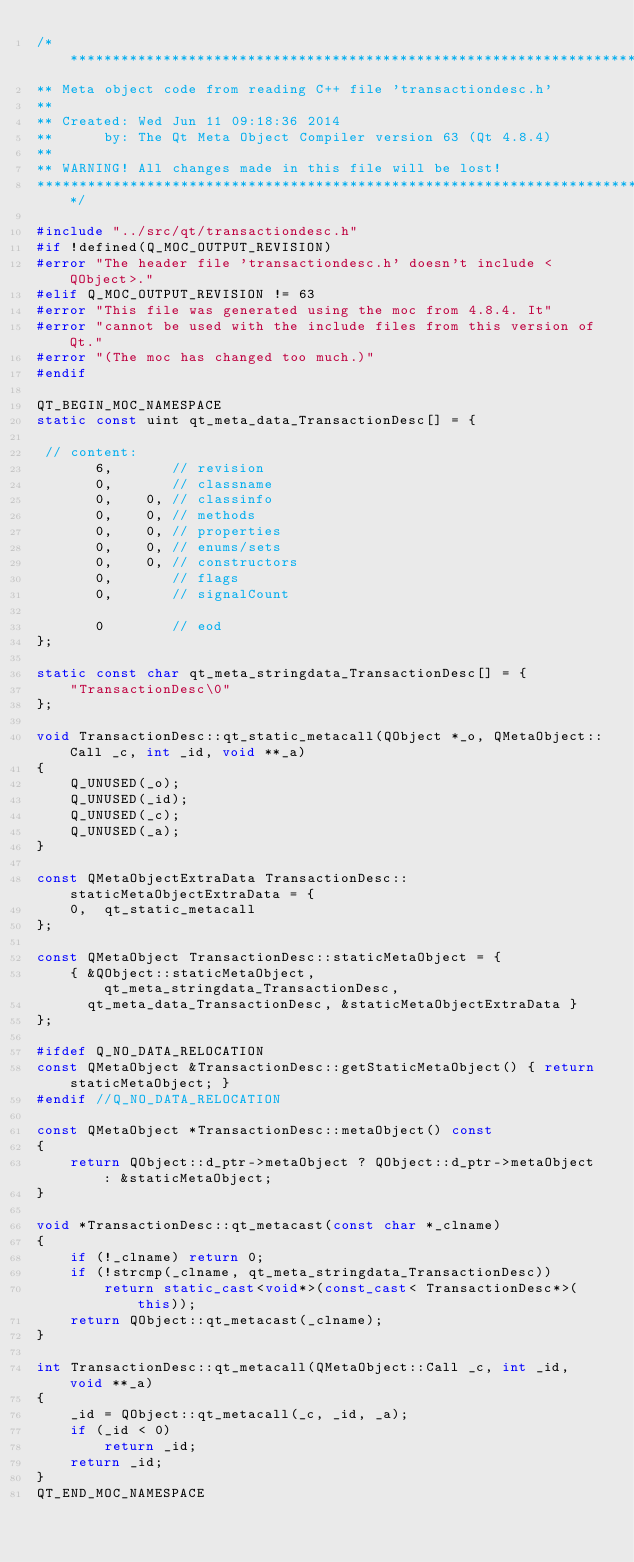Convert code to text. <code><loc_0><loc_0><loc_500><loc_500><_C++_>/****************************************************************************
** Meta object code from reading C++ file 'transactiondesc.h'
**
** Created: Wed Jun 11 09:18:36 2014
**      by: The Qt Meta Object Compiler version 63 (Qt 4.8.4)
**
** WARNING! All changes made in this file will be lost!
*****************************************************************************/

#include "../src/qt/transactiondesc.h"
#if !defined(Q_MOC_OUTPUT_REVISION)
#error "The header file 'transactiondesc.h' doesn't include <QObject>."
#elif Q_MOC_OUTPUT_REVISION != 63
#error "This file was generated using the moc from 4.8.4. It"
#error "cannot be used with the include files from this version of Qt."
#error "(The moc has changed too much.)"
#endif

QT_BEGIN_MOC_NAMESPACE
static const uint qt_meta_data_TransactionDesc[] = {

 // content:
       6,       // revision
       0,       // classname
       0,    0, // classinfo
       0,    0, // methods
       0,    0, // properties
       0,    0, // enums/sets
       0,    0, // constructors
       0,       // flags
       0,       // signalCount

       0        // eod
};

static const char qt_meta_stringdata_TransactionDesc[] = {
    "TransactionDesc\0"
};

void TransactionDesc::qt_static_metacall(QObject *_o, QMetaObject::Call _c, int _id, void **_a)
{
    Q_UNUSED(_o);
    Q_UNUSED(_id);
    Q_UNUSED(_c);
    Q_UNUSED(_a);
}

const QMetaObjectExtraData TransactionDesc::staticMetaObjectExtraData = {
    0,  qt_static_metacall 
};

const QMetaObject TransactionDesc::staticMetaObject = {
    { &QObject::staticMetaObject, qt_meta_stringdata_TransactionDesc,
      qt_meta_data_TransactionDesc, &staticMetaObjectExtraData }
};

#ifdef Q_NO_DATA_RELOCATION
const QMetaObject &TransactionDesc::getStaticMetaObject() { return staticMetaObject; }
#endif //Q_NO_DATA_RELOCATION

const QMetaObject *TransactionDesc::metaObject() const
{
    return QObject::d_ptr->metaObject ? QObject::d_ptr->metaObject : &staticMetaObject;
}

void *TransactionDesc::qt_metacast(const char *_clname)
{
    if (!_clname) return 0;
    if (!strcmp(_clname, qt_meta_stringdata_TransactionDesc))
        return static_cast<void*>(const_cast< TransactionDesc*>(this));
    return QObject::qt_metacast(_clname);
}

int TransactionDesc::qt_metacall(QMetaObject::Call _c, int _id, void **_a)
{
    _id = QObject::qt_metacall(_c, _id, _a);
    if (_id < 0)
        return _id;
    return _id;
}
QT_END_MOC_NAMESPACE
</code> 